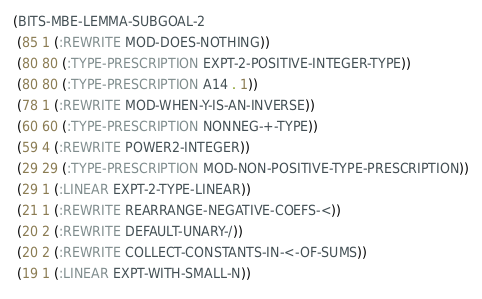Convert code to text. <code><loc_0><loc_0><loc_500><loc_500><_Lisp_>(BITS-MBE-LEMMA-SUBGOAL-2
 (85 1 (:REWRITE MOD-DOES-NOTHING))
 (80 80 (:TYPE-PRESCRIPTION EXPT-2-POSITIVE-INTEGER-TYPE))
 (80 80 (:TYPE-PRESCRIPTION A14 . 1))
 (78 1 (:REWRITE MOD-WHEN-Y-IS-AN-INVERSE))
 (60 60 (:TYPE-PRESCRIPTION NONNEG-+-TYPE))
 (59 4 (:REWRITE POWER2-INTEGER))
 (29 29 (:TYPE-PRESCRIPTION MOD-NON-POSITIVE-TYPE-PRESCRIPTION))
 (29 1 (:LINEAR EXPT-2-TYPE-LINEAR))
 (21 1 (:REWRITE REARRANGE-NEGATIVE-COEFS-<))
 (20 2 (:REWRITE DEFAULT-UNARY-/))
 (20 2 (:REWRITE COLLECT-CONSTANTS-IN-<-OF-SUMS))
 (19 1 (:LINEAR EXPT-WITH-SMALL-N))</code> 